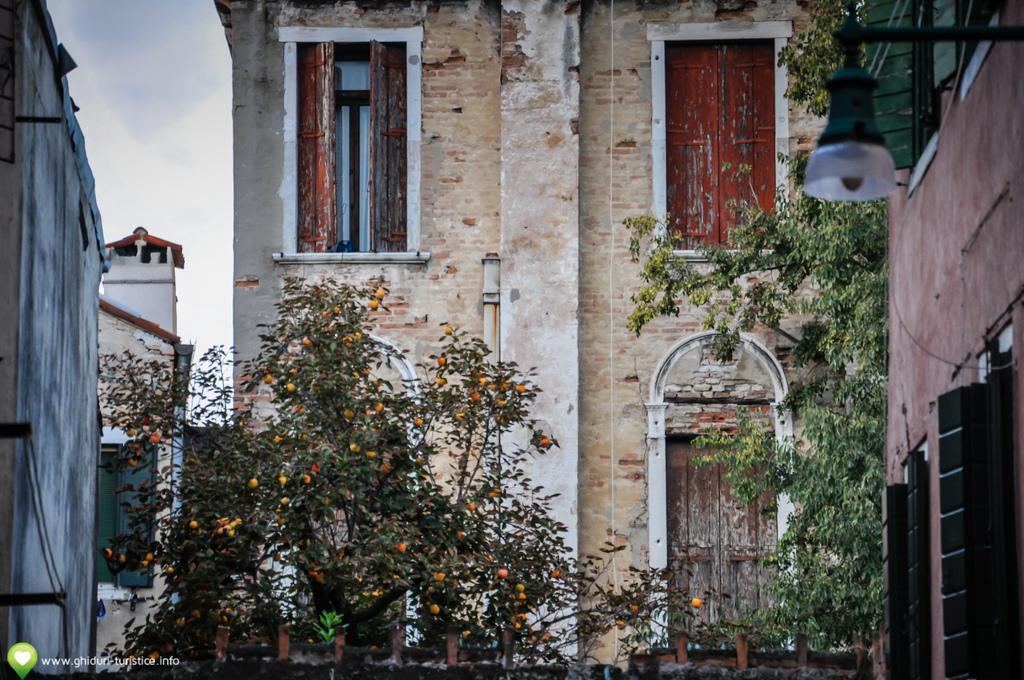Please provide a concise description of this image. This image consists of a building along with a window and a door. At the bottom, there are plants. At the top, there is a sky. 